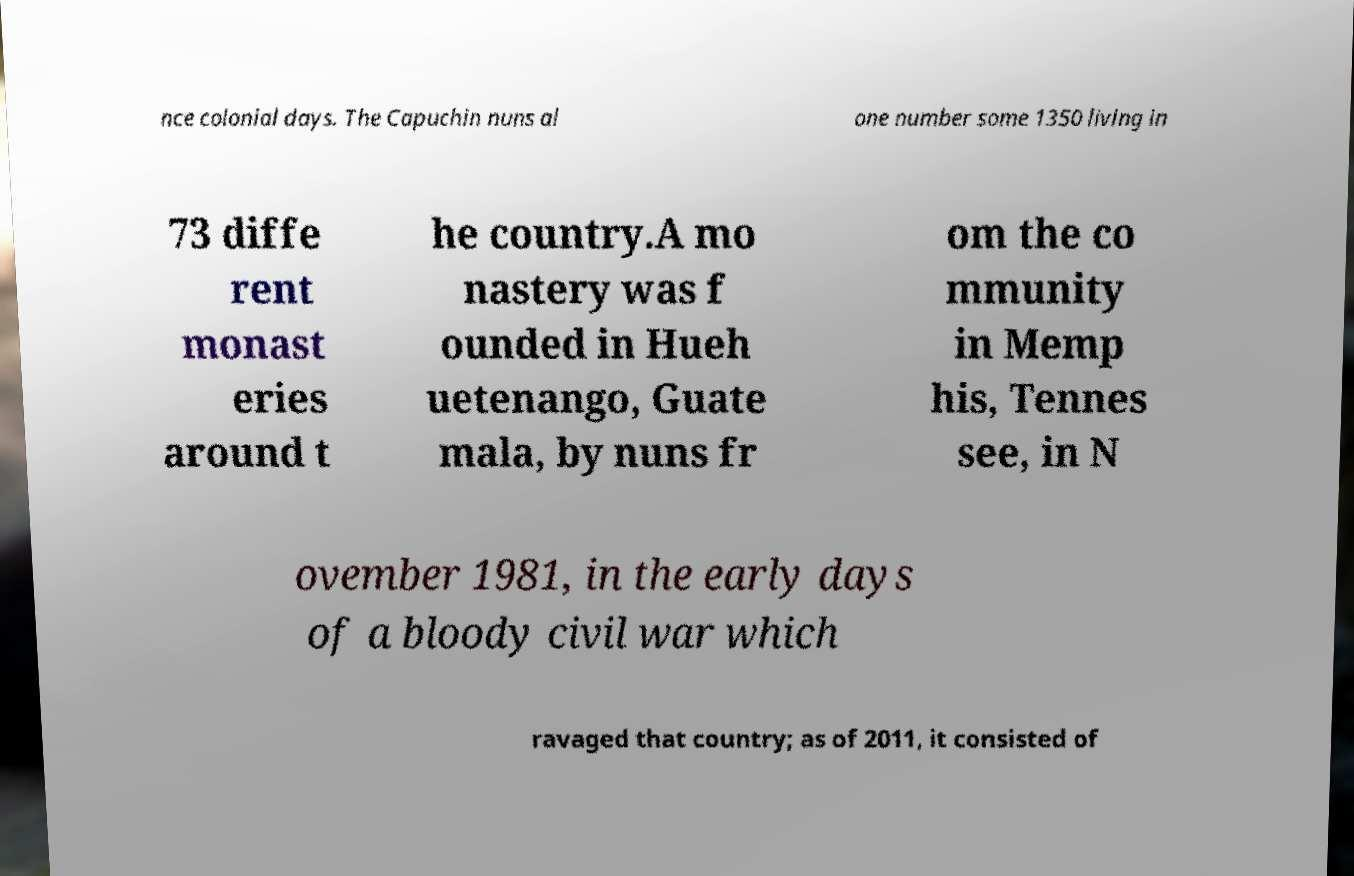Can you accurately transcribe the text from the provided image for me? nce colonial days. The Capuchin nuns al one number some 1350 living in 73 diffe rent monast eries around t he country.A mo nastery was f ounded in Hueh uetenango, Guate mala, by nuns fr om the co mmunity in Memp his, Tennes see, in N ovember 1981, in the early days of a bloody civil war which ravaged that country; as of 2011, it consisted of 